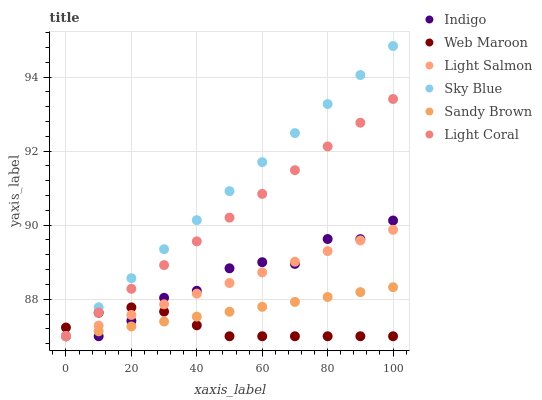Does Web Maroon have the minimum area under the curve?
Answer yes or no. Yes. Does Sky Blue have the maximum area under the curve?
Answer yes or no. Yes. Does Indigo have the minimum area under the curve?
Answer yes or no. No. Does Indigo have the maximum area under the curve?
Answer yes or no. No. Is Sky Blue the smoothest?
Answer yes or no. Yes. Is Indigo the roughest?
Answer yes or no. Yes. Is Web Maroon the smoothest?
Answer yes or no. No. Is Web Maroon the roughest?
Answer yes or no. No. Does Light Salmon have the lowest value?
Answer yes or no. Yes. Does Sky Blue have the highest value?
Answer yes or no. Yes. Does Indigo have the highest value?
Answer yes or no. No. Does Sandy Brown intersect Light Coral?
Answer yes or no. Yes. Is Sandy Brown less than Light Coral?
Answer yes or no. No. Is Sandy Brown greater than Light Coral?
Answer yes or no. No. 